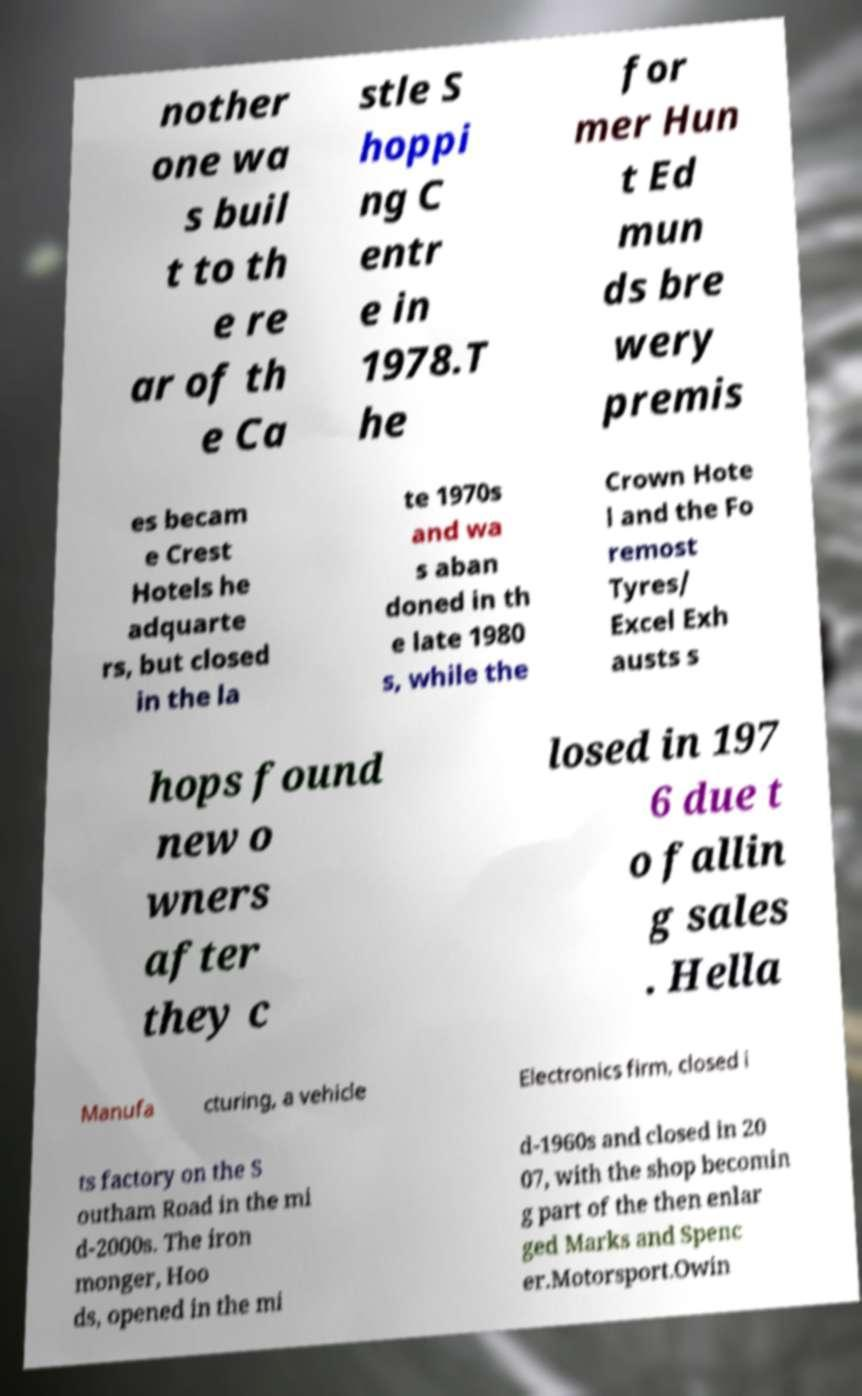Could you extract and type out the text from this image? nother one wa s buil t to th e re ar of th e Ca stle S hoppi ng C entr e in 1978.T he for mer Hun t Ed mun ds bre wery premis es becam e Crest Hotels he adquarte rs, but closed in the la te 1970s and wa s aban doned in th e late 1980 s, while the Crown Hote l and the Fo remost Tyres/ Excel Exh austs s hops found new o wners after they c losed in 197 6 due t o fallin g sales . Hella Manufa cturing, a vehicle Electronics firm, closed i ts factory on the S outham Road in the mi d-2000s. The iron monger, Hoo ds, opened in the mi d-1960s and closed in 20 07, with the shop becomin g part of the then enlar ged Marks and Spenc er.Motorsport.Owin 